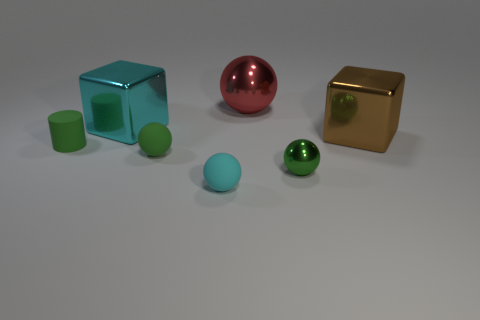Subtract all purple balls. Subtract all cyan cylinders. How many balls are left? 4 Add 1 small green balls. How many objects exist? 8 Subtract all cylinders. How many objects are left? 6 Add 2 tiny green metallic things. How many tiny green metallic things are left? 3 Add 1 green things. How many green things exist? 4 Subtract 0 brown spheres. How many objects are left? 7 Subtract all red spheres. Subtract all big metal cubes. How many objects are left? 4 